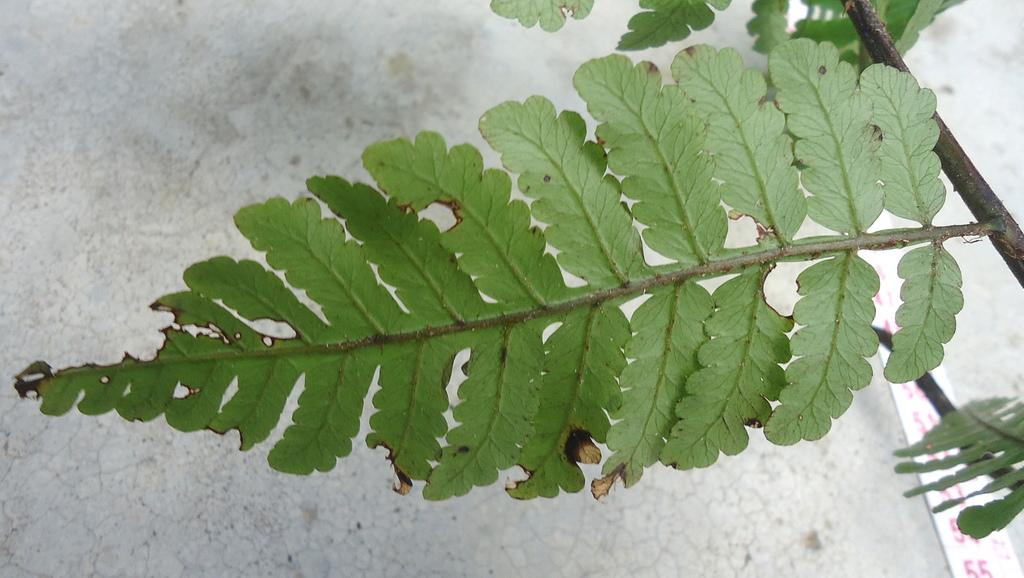What type of plant material can be seen in the image? There are leaves in the image. What part of the plant is connected to the leaves in the image? There is a stem in the image. How does the cracker contribute to the digestion process in the image? There is no cracker present in the image, and therefore it cannot contribute to any digestion process. 